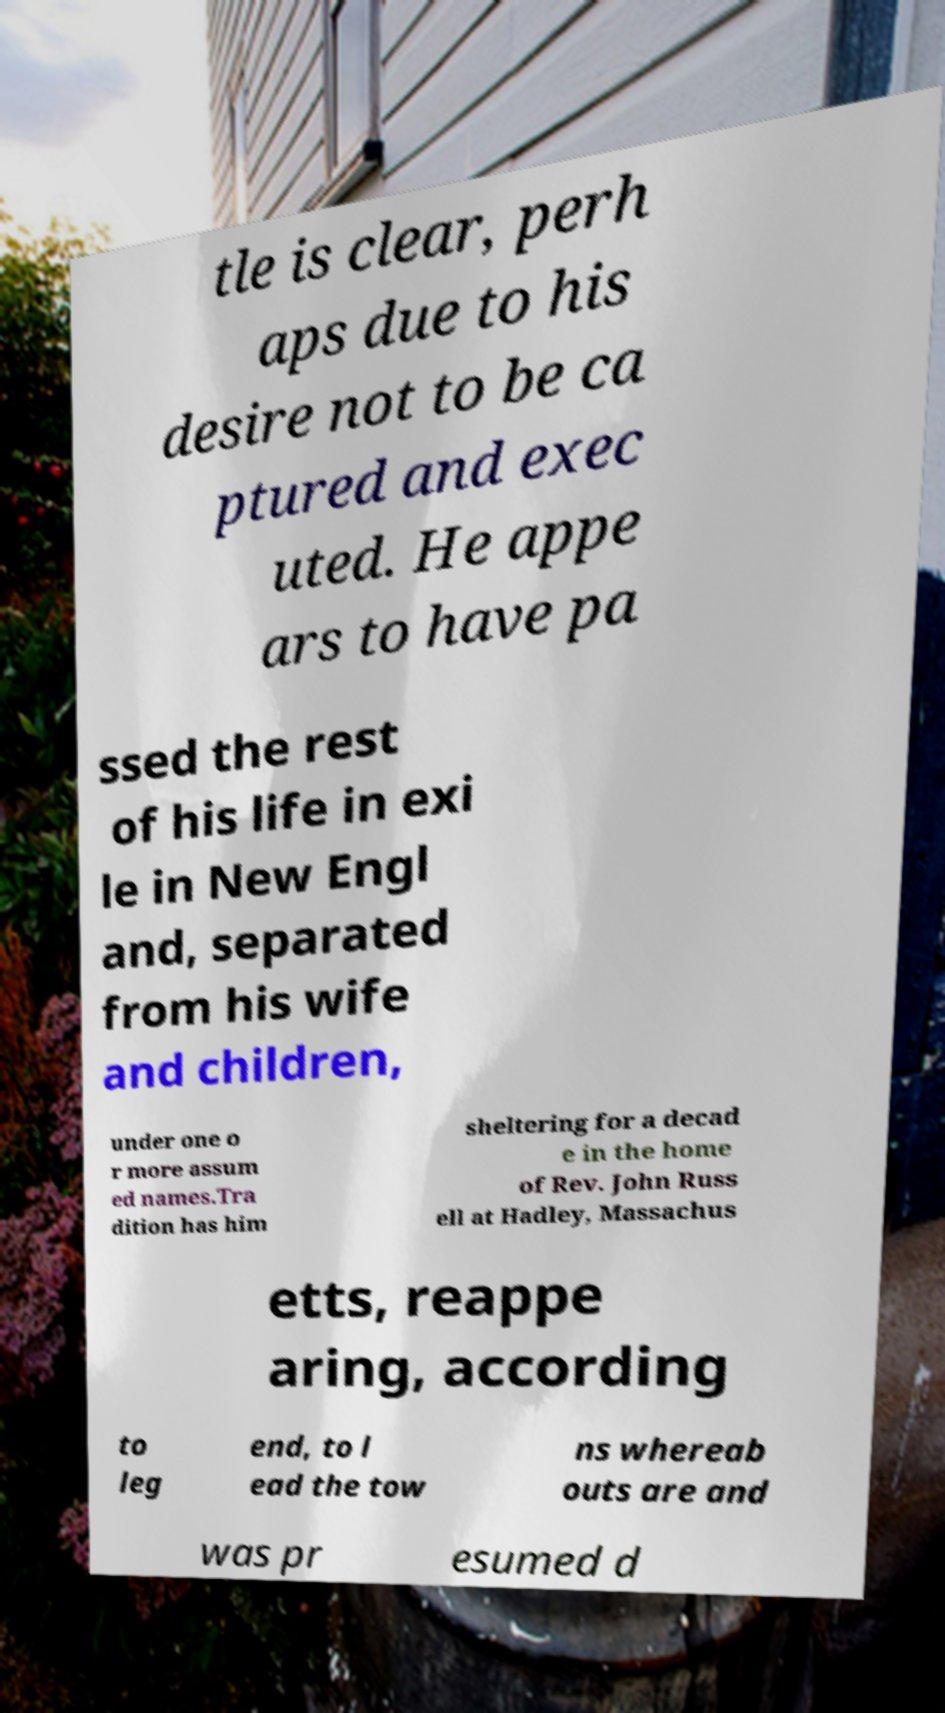What messages or text are displayed in this image? I need them in a readable, typed format. tle is clear, perh aps due to his desire not to be ca ptured and exec uted. He appe ars to have pa ssed the rest of his life in exi le in New Engl and, separated from his wife and children, under one o r more assum ed names.Tra dition has him sheltering for a decad e in the home of Rev. John Russ ell at Hadley, Massachus etts, reappe aring, according to leg end, to l ead the tow ns whereab outs are and was pr esumed d 